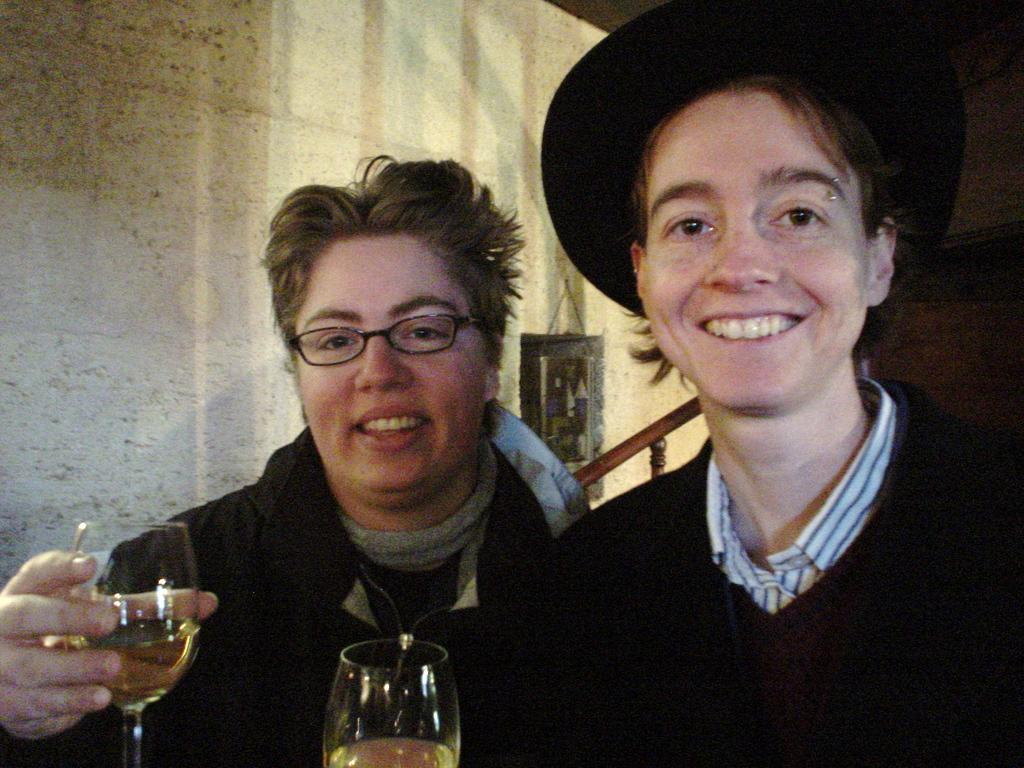How many people are in the image? There are two persons in the image. What are the two persons holding in their hands? The two persons are holding a glass each. What can be seen in the background of the image? There is a wall and stairs in the background of the image. How much paint is on the sponge in the image? There is no paint or sponge present in the image. 